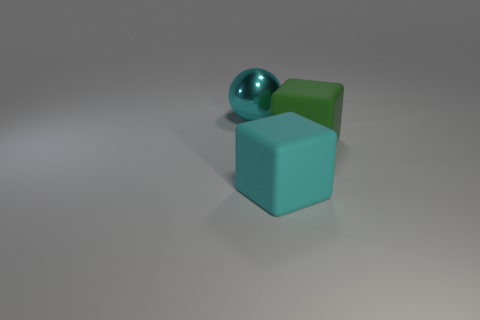What sort of materials do the objects appear to be made from, based on their appearance? Based on their appearance, the spherical object seems to be made of a glossy material such as polished metal or glass, reflecting light and surroundings with a high degree of shine. The cubes look like they could be made of a matte substance, perhaps plastic or rubber, as they absorb light and have a less reflective surface. Their surfaces are smooth, and the soft shadows they cast suggest they are solid and opaque. 